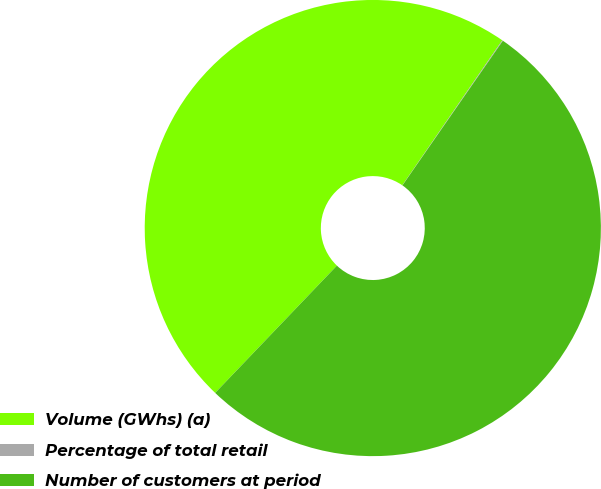Convert chart. <chart><loc_0><loc_0><loc_500><loc_500><pie_chart><fcel>Volume (GWhs) (a)<fcel>Percentage of total retail<fcel>Number of customers at period<nl><fcel>47.46%<fcel>0.05%<fcel>52.48%<nl></chart> 